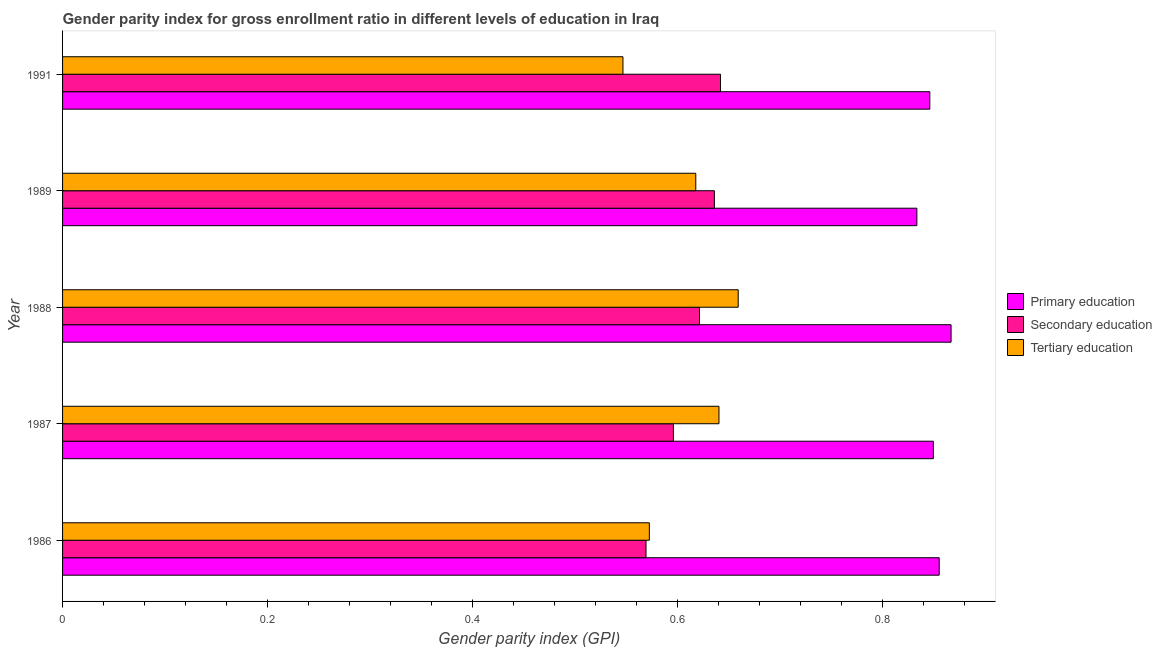How many groups of bars are there?
Offer a terse response. 5. Are the number of bars per tick equal to the number of legend labels?
Your answer should be compact. Yes. How many bars are there on the 5th tick from the top?
Make the answer very short. 3. How many bars are there on the 1st tick from the bottom?
Your response must be concise. 3. What is the label of the 3rd group of bars from the top?
Your answer should be very brief. 1988. In how many cases, is the number of bars for a given year not equal to the number of legend labels?
Provide a short and direct response. 0. What is the gender parity index in primary education in 1991?
Your answer should be very brief. 0.85. Across all years, what is the maximum gender parity index in secondary education?
Provide a short and direct response. 0.64. Across all years, what is the minimum gender parity index in secondary education?
Make the answer very short. 0.57. In which year was the gender parity index in secondary education maximum?
Your answer should be very brief. 1991. What is the total gender parity index in secondary education in the graph?
Provide a succinct answer. 3.07. What is the difference between the gender parity index in tertiary education in 1988 and that in 1989?
Keep it short and to the point. 0.04. What is the difference between the gender parity index in primary education in 1988 and the gender parity index in tertiary education in 1991?
Offer a very short reply. 0.32. What is the average gender parity index in primary education per year?
Give a very brief answer. 0.85. In the year 1986, what is the difference between the gender parity index in secondary education and gender parity index in primary education?
Offer a terse response. -0.29. What is the ratio of the gender parity index in primary education in 1988 to that in 1989?
Ensure brevity in your answer.  1.04. Is the difference between the gender parity index in secondary education in 1986 and 1991 greater than the difference between the gender parity index in tertiary education in 1986 and 1991?
Offer a terse response. No. What is the difference between the highest and the second highest gender parity index in primary education?
Provide a succinct answer. 0.01. What is the difference between the highest and the lowest gender parity index in primary education?
Offer a terse response. 0.03. In how many years, is the gender parity index in primary education greater than the average gender parity index in primary education taken over all years?
Give a very brief answer. 2. Is the sum of the gender parity index in primary education in 1988 and 1989 greater than the maximum gender parity index in tertiary education across all years?
Offer a very short reply. Yes. What does the 2nd bar from the top in 1989 represents?
Offer a very short reply. Secondary education. What does the 2nd bar from the bottom in 1987 represents?
Offer a very short reply. Secondary education. What is the difference between two consecutive major ticks on the X-axis?
Offer a terse response. 0.2. Does the graph contain grids?
Make the answer very short. No. How many legend labels are there?
Your answer should be very brief. 3. How are the legend labels stacked?
Provide a short and direct response. Vertical. What is the title of the graph?
Give a very brief answer. Gender parity index for gross enrollment ratio in different levels of education in Iraq. What is the label or title of the X-axis?
Ensure brevity in your answer.  Gender parity index (GPI). What is the Gender parity index (GPI) in Primary education in 1986?
Your answer should be compact. 0.86. What is the Gender parity index (GPI) of Secondary education in 1986?
Your answer should be compact. 0.57. What is the Gender parity index (GPI) in Tertiary education in 1986?
Offer a very short reply. 0.57. What is the Gender parity index (GPI) in Primary education in 1987?
Provide a succinct answer. 0.85. What is the Gender parity index (GPI) of Secondary education in 1987?
Make the answer very short. 0.6. What is the Gender parity index (GPI) in Tertiary education in 1987?
Your answer should be compact. 0.64. What is the Gender parity index (GPI) of Primary education in 1988?
Offer a terse response. 0.87. What is the Gender parity index (GPI) in Secondary education in 1988?
Your response must be concise. 0.62. What is the Gender parity index (GPI) in Tertiary education in 1988?
Ensure brevity in your answer.  0.66. What is the Gender parity index (GPI) in Primary education in 1989?
Make the answer very short. 0.83. What is the Gender parity index (GPI) of Secondary education in 1989?
Provide a short and direct response. 0.64. What is the Gender parity index (GPI) of Tertiary education in 1989?
Ensure brevity in your answer.  0.62. What is the Gender parity index (GPI) in Primary education in 1991?
Your response must be concise. 0.85. What is the Gender parity index (GPI) in Secondary education in 1991?
Provide a short and direct response. 0.64. What is the Gender parity index (GPI) in Tertiary education in 1991?
Offer a very short reply. 0.55. Across all years, what is the maximum Gender parity index (GPI) of Primary education?
Keep it short and to the point. 0.87. Across all years, what is the maximum Gender parity index (GPI) in Secondary education?
Provide a short and direct response. 0.64. Across all years, what is the maximum Gender parity index (GPI) in Tertiary education?
Your response must be concise. 0.66. Across all years, what is the minimum Gender parity index (GPI) of Primary education?
Your answer should be very brief. 0.83. Across all years, what is the minimum Gender parity index (GPI) of Secondary education?
Offer a very short reply. 0.57. Across all years, what is the minimum Gender parity index (GPI) of Tertiary education?
Your answer should be compact. 0.55. What is the total Gender parity index (GPI) of Primary education in the graph?
Make the answer very short. 4.25. What is the total Gender parity index (GPI) of Secondary education in the graph?
Make the answer very short. 3.07. What is the total Gender parity index (GPI) in Tertiary education in the graph?
Give a very brief answer. 3.04. What is the difference between the Gender parity index (GPI) in Primary education in 1986 and that in 1987?
Your response must be concise. 0.01. What is the difference between the Gender parity index (GPI) of Secondary education in 1986 and that in 1987?
Provide a short and direct response. -0.03. What is the difference between the Gender parity index (GPI) of Tertiary education in 1986 and that in 1987?
Make the answer very short. -0.07. What is the difference between the Gender parity index (GPI) in Primary education in 1986 and that in 1988?
Your answer should be compact. -0.01. What is the difference between the Gender parity index (GPI) of Secondary education in 1986 and that in 1988?
Your answer should be very brief. -0.05. What is the difference between the Gender parity index (GPI) in Tertiary education in 1986 and that in 1988?
Your answer should be very brief. -0.09. What is the difference between the Gender parity index (GPI) of Primary education in 1986 and that in 1989?
Make the answer very short. 0.02. What is the difference between the Gender parity index (GPI) of Secondary education in 1986 and that in 1989?
Your answer should be compact. -0.07. What is the difference between the Gender parity index (GPI) in Tertiary education in 1986 and that in 1989?
Offer a very short reply. -0.05. What is the difference between the Gender parity index (GPI) in Primary education in 1986 and that in 1991?
Your answer should be compact. 0.01. What is the difference between the Gender parity index (GPI) of Secondary education in 1986 and that in 1991?
Provide a succinct answer. -0.07. What is the difference between the Gender parity index (GPI) in Tertiary education in 1986 and that in 1991?
Offer a terse response. 0.03. What is the difference between the Gender parity index (GPI) of Primary education in 1987 and that in 1988?
Offer a very short reply. -0.02. What is the difference between the Gender parity index (GPI) in Secondary education in 1987 and that in 1988?
Offer a very short reply. -0.03. What is the difference between the Gender parity index (GPI) in Tertiary education in 1987 and that in 1988?
Ensure brevity in your answer.  -0.02. What is the difference between the Gender parity index (GPI) of Primary education in 1987 and that in 1989?
Provide a short and direct response. 0.02. What is the difference between the Gender parity index (GPI) of Secondary education in 1987 and that in 1989?
Make the answer very short. -0.04. What is the difference between the Gender parity index (GPI) of Tertiary education in 1987 and that in 1989?
Keep it short and to the point. 0.02. What is the difference between the Gender parity index (GPI) in Primary education in 1987 and that in 1991?
Your answer should be compact. 0. What is the difference between the Gender parity index (GPI) in Secondary education in 1987 and that in 1991?
Provide a short and direct response. -0.05. What is the difference between the Gender parity index (GPI) in Tertiary education in 1987 and that in 1991?
Offer a terse response. 0.09. What is the difference between the Gender parity index (GPI) of Primary education in 1988 and that in 1989?
Ensure brevity in your answer.  0.03. What is the difference between the Gender parity index (GPI) of Secondary education in 1988 and that in 1989?
Give a very brief answer. -0.01. What is the difference between the Gender parity index (GPI) of Tertiary education in 1988 and that in 1989?
Provide a succinct answer. 0.04. What is the difference between the Gender parity index (GPI) of Primary education in 1988 and that in 1991?
Ensure brevity in your answer.  0.02. What is the difference between the Gender parity index (GPI) in Secondary education in 1988 and that in 1991?
Give a very brief answer. -0.02. What is the difference between the Gender parity index (GPI) in Tertiary education in 1988 and that in 1991?
Provide a succinct answer. 0.11. What is the difference between the Gender parity index (GPI) of Primary education in 1989 and that in 1991?
Provide a succinct answer. -0.01. What is the difference between the Gender parity index (GPI) in Secondary education in 1989 and that in 1991?
Offer a terse response. -0.01. What is the difference between the Gender parity index (GPI) of Tertiary education in 1989 and that in 1991?
Your answer should be very brief. 0.07. What is the difference between the Gender parity index (GPI) in Primary education in 1986 and the Gender parity index (GPI) in Secondary education in 1987?
Keep it short and to the point. 0.26. What is the difference between the Gender parity index (GPI) in Primary education in 1986 and the Gender parity index (GPI) in Tertiary education in 1987?
Offer a very short reply. 0.21. What is the difference between the Gender parity index (GPI) in Secondary education in 1986 and the Gender parity index (GPI) in Tertiary education in 1987?
Make the answer very short. -0.07. What is the difference between the Gender parity index (GPI) of Primary education in 1986 and the Gender parity index (GPI) of Secondary education in 1988?
Your answer should be compact. 0.23. What is the difference between the Gender parity index (GPI) in Primary education in 1986 and the Gender parity index (GPI) in Tertiary education in 1988?
Your answer should be compact. 0.2. What is the difference between the Gender parity index (GPI) in Secondary education in 1986 and the Gender parity index (GPI) in Tertiary education in 1988?
Your response must be concise. -0.09. What is the difference between the Gender parity index (GPI) in Primary education in 1986 and the Gender parity index (GPI) in Secondary education in 1989?
Your response must be concise. 0.22. What is the difference between the Gender parity index (GPI) of Primary education in 1986 and the Gender parity index (GPI) of Tertiary education in 1989?
Offer a terse response. 0.24. What is the difference between the Gender parity index (GPI) in Secondary education in 1986 and the Gender parity index (GPI) in Tertiary education in 1989?
Ensure brevity in your answer.  -0.05. What is the difference between the Gender parity index (GPI) in Primary education in 1986 and the Gender parity index (GPI) in Secondary education in 1991?
Make the answer very short. 0.21. What is the difference between the Gender parity index (GPI) of Primary education in 1986 and the Gender parity index (GPI) of Tertiary education in 1991?
Offer a terse response. 0.31. What is the difference between the Gender parity index (GPI) of Secondary education in 1986 and the Gender parity index (GPI) of Tertiary education in 1991?
Offer a very short reply. 0.02. What is the difference between the Gender parity index (GPI) in Primary education in 1987 and the Gender parity index (GPI) in Secondary education in 1988?
Make the answer very short. 0.23. What is the difference between the Gender parity index (GPI) in Primary education in 1987 and the Gender parity index (GPI) in Tertiary education in 1988?
Your response must be concise. 0.19. What is the difference between the Gender parity index (GPI) in Secondary education in 1987 and the Gender parity index (GPI) in Tertiary education in 1988?
Ensure brevity in your answer.  -0.06. What is the difference between the Gender parity index (GPI) of Primary education in 1987 and the Gender parity index (GPI) of Secondary education in 1989?
Keep it short and to the point. 0.21. What is the difference between the Gender parity index (GPI) in Primary education in 1987 and the Gender parity index (GPI) in Tertiary education in 1989?
Your answer should be compact. 0.23. What is the difference between the Gender parity index (GPI) of Secondary education in 1987 and the Gender parity index (GPI) of Tertiary education in 1989?
Offer a terse response. -0.02. What is the difference between the Gender parity index (GPI) of Primary education in 1987 and the Gender parity index (GPI) of Secondary education in 1991?
Provide a succinct answer. 0.21. What is the difference between the Gender parity index (GPI) of Primary education in 1987 and the Gender parity index (GPI) of Tertiary education in 1991?
Ensure brevity in your answer.  0.3. What is the difference between the Gender parity index (GPI) in Secondary education in 1987 and the Gender parity index (GPI) in Tertiary education in 1991?
Your answer should be compact. 0.05. What is the difference between the Gender parity index (GPI) of Primary education in 1988 and the Gender parity index (GPI) of Secondary education in 1989?
Offer a very short reply. 0.23. What is the difference between the Gender parity index (GPI) in Primary education in 1988 and the Gender parity index (GPI) in Tertiary education in 1989?
Offer a very short reply. 0.25. What is the difference between the Gender parity index (GPI) in Secondary education in 1988 and the Gender parity index (GPI) in Tertiary education in 1989?
Provide a succinct answer. 0. What is the difference between the Gender parity index (GPI) of Primary education in 1988 and the Gender parity index (GPI) of Secondary education in 1991?
Offer a very short reply. 0.23. What is the difference between the Gender parity index (GPI) of Primary education in 1988 and the Gender parity index (GPI) of Tertiary education in 1991?
Provide a succinct answer. 0.32. What is the difference between the Gender parity index (GPI) of Secondary education in 1988 and the Gender parity index (GPI) of Tertiary education in 1991?
Offer a terse response. 0.07. What is the difference between the Gender parity index (GPI) in Primary education in 1989 and the Gender parity index (GPI) in Secondary education in 1991?
Offer a very short reply. 0.19. What is the difference between the Gender parity index (GPI) in Primary education in 1989 and the Gender parity index (GPI) in Tertiary education in 1991?
Ensure brevity in your answer.  0.29. What is the difference between the Gender parity index (GPI) in Secondary education in 1989 and the Gender parity index (GPI) in Tertiary education in 1991?
Make the answer very short. 0.09. What is the average Gender parity index (GPI) of Primary education per year?
Your answer should be very brief. 0.85. What is the average Gender parity index (GPI) in Secondary education per year?
Provide a succinct answer. 0.61. What is the average Gender parity index (GPI) of Tertiary education per year?
Offer a terse response. 0.61. In the year 1986, what is the difference between the Gender parity index (GPI) in Primary education and Gender parity index (GPI) in Secondary education?
Provide a succinct answer. 0.29. In the year 1986, what is the difference between the Gender parity index (GPI) in Primary education and Gender parity index (GPI) in Tertiary education?
Provide a short and direct response. 0.28. In the year 1986, what is the difference between the Gender parity index (GPI) of Secondary education and Gender parity index (GPI) of Tertiary education?
Provide a short and direct response. -0. In the year 1987, what is the difference between the Gender parity index (GPI) in Primary education and Gender parity index (GPI) in Secondary education?
Your answer should be very brief. 0.25. In the year 1987, what is the difference between the Gender parity index (GPI) of Primary education and Gender parity index (GPI) of Tertiary education?
Your answer should be very brief. 0.21. In the year 1987, what is the difference between the Gender parity index (GPI) of Secondary education and Gender parity index (GPI) of Tertiary education?
Offer a very short reply. -0.04. In the year 1988, what is the difference between the Gender parity index (GPI) of Primary education and Gender parity index (GPI) of Secondary education?
Provide a succinct answer. 0.25. In the year 1988, what is the difference between the Gender parity index (GPI) of Primary education and Gender parity index (GPI) of Tertiary education?
Your answer should be very brief. 0.21. In the year 1988, what is the difference between the Gender parity index (GPI) in Secondary education and Gender parity index (GPI) in Tertiary education?
Ensure brevity in your answer.  -0.04. In the year 1989, what is the difference between the Gender parity index (GPI) of Primary education and Gender parity index (GPI) of Secondary education?
Your answer should be very brief. 0.2. In the year 1989, what is the difference between the Gender parity index (GPI) in Primary education and Gender parity index (GPI) in Tertiary education?
Ensure brevity in your answer.  0.22. In the year 1989, what is the difference between the Gender parity index (GPI) of Secondary education and Gender parity index (GPI) of Tertiary education?
Give a very brief answer. 0.02. In the year 1991, what is the difference between the Gender parity index (GPI) of Primary education and Gender parity index (GPI) of Secondary education?
Offer a terse response. 0.2. In the year 1991, what is the difference between the Gender parity index (GPI) of Primary education and Gender parity index (GPI) of Tertiary education?
Your answer should be compact. 0.3. In the year 1991, what is the difference between the Gender parity index (GPI) in Secondary education and Gender parity index (GPI) in Tertiary education?
Provide a short and direct response. 0.1. What is the ratio of the Gender parity index (GPI) of Secondary education in 1986 to that in 1987?
Your response must be concise. 0.96. What is the ratio of the Gender parity index (GPI) in Tertiary education in 1986 to that in 1987?
Offer a very short reply. 0.89. What is the ratio of the Gender parity index (GPI) in Primary education in 1986 to that in 1988?
Offer a very short reply. 0.99. What is the ratio of the Gender parity index (GPI) of Secondary education in 1986 to that in 1988?
Provide a short and direct response. 0.92. What is the ratio of the Gender parity index (GPI) in Tertiary education in 1986 to that in 1988?
Provide a short and direct response. 0.87. What is the ratio of the Gender parity index (GPI) of Primary education in 1986 to that in 1989?
Offer a terse response. 1.03. What is the ratio of the Gender parity index (GPI) of Secondary education in 1986 to that in 1989?
Give a very brief answer. 0.9. What is the ratio of the Gender parity index (GPI) in Tertiary education in 1986 to that in 1989?
Offer a very short reply. 0.93. What is the ratio of the Gender parity index (GPI) of Primary education in 1986 to that in 1991?
Your response must be concise. 1.01. What is the ratio of the Gender parity index (GPI) in Secondary education in 1986 to that in 1991?
Offer a terse response. 0.89. What is the ratio of the Gender parity index (GPI) in Tertiary education in 1986 to that in 1991?
Your response must be concise. 1.05. What is the ratio of the Gender parity index (GPI) of Primary education in 1987 to that in 1988?
Provide a short and direct response. 0.98. What is the ratio of the Gender parity index (GPI) of Secondary education in 1987 to that in 1988?
Offer a terse response. 0.96. What is the ratio of the Gender parity index (GPI) in Tertiary education in 1987 to that in 1988?
Your answer should be compact. 0.97. What is the ratio of the Gender parity index (GPI) of Primary education in 1987 to that in 1989?
Keep it short and to the point. 1.02. What is the ratio of the Gender parity index (GPI) of Secondary education in 1987 to that in 1989?
Offer a very short reply. 0.94. What is the ratio of the Gender parity index (GPI) in Tertiary education in 1987 to that in 1989?
Provide a short and direct response. 1.04. What is the ratio of the Gender parity index (GPI) in Primary education in 1987 to that in 1991?
Provide a succinct answer. 1. What is the ratio of the Gender parity index (GPI) of Secondary education in 1987 to that in 1991?
Provide a succinct answer. 0.93. What is the ratio of the Gender parity index (GPI) in Tertiary education in 1987 to that in 1991?
Provide a succinct answer. 1.17. What is the ratio of the Gender parity index (GPI) in Primary education in 1988 to that in 1989?
Your answer should be very brief. 1.04. What is the ratio of the Gender parity index (GPI) in Secondary education in 1988 to that in 1989?
Offer a very short reply. 0.98. What is the ratio of the Gender parity index (GPI) of Tertiary education in 1988 to that in 1989?
Provide a succinct answer. 1.07. What is the ratio of the Gender parity index (GPI) of Primary education in 1988 to that in 1991?
Offer a very short reply. 1.02. What is the ratio of the Gender parity index (GPI) in Secondary education in 1988 to that in 1991?
Your answer should be very brief. 0.97. What is the ratio of the Gender parity index (GPI) in Tertiary education in 1988 to that in 1991?
Offer a very short reply. 1.21. What is the ratio of the Gender parity index (GPI) in Primary education in 1989 to that in 1991?
Your answer should be compact. 0.99. What is the ratio of the Gender parity index (GPI) of Tertiary education in 1989 to that in 1991?
Your answer should be compact. 1.13. What is the difference between the highest and the second highest Gender parity index (GPI) in Primary education?
Offer a terse response. 0.01. What is the difference between the highest and the second highest Gender parity index (GPI) in Secondary education?
Make the answer very short. 0.01. What is the difference between the highest and the second highest Gender parity index (GPI) of Tertiary education?
Provide a short and direct response. 0.02. What is the difference between the highest and the lowest Gender parity index (GPI) in Primary education?
Provide a short and direct response. 0.03. What is the difference between the highest and the lowest Gender parity index (GPI) in Secondary education?
Ensure brevity in your answer.  0.07. What is the difference between the highest and the lowest Gender parity index (GPI) of Tertiary education?
Your answer should be very brief. 0.11. 